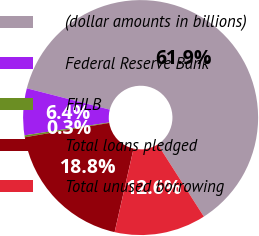<chart> <loc_0><loc_0><loc_500><loc_500><pie_chart><fcel>(dollar amounts in billions)<fcel>Federal Reserve Bank<fcel>FHLB<fcel>Total loans pledged<fcel>Total unused borrowing<nl><fcel>61.96%<fcel>6.43%<fcel>0.26%<fcel>18.77%<fcel>12.6%<nl></chart> 